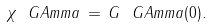Convert formula to latex. <formula><loc_0><loc_0><loc_500><loc_500>\chi _ { \ } G A m m a \, = \, G _ { \ } G A m m a ( 0 ) .</formula> 